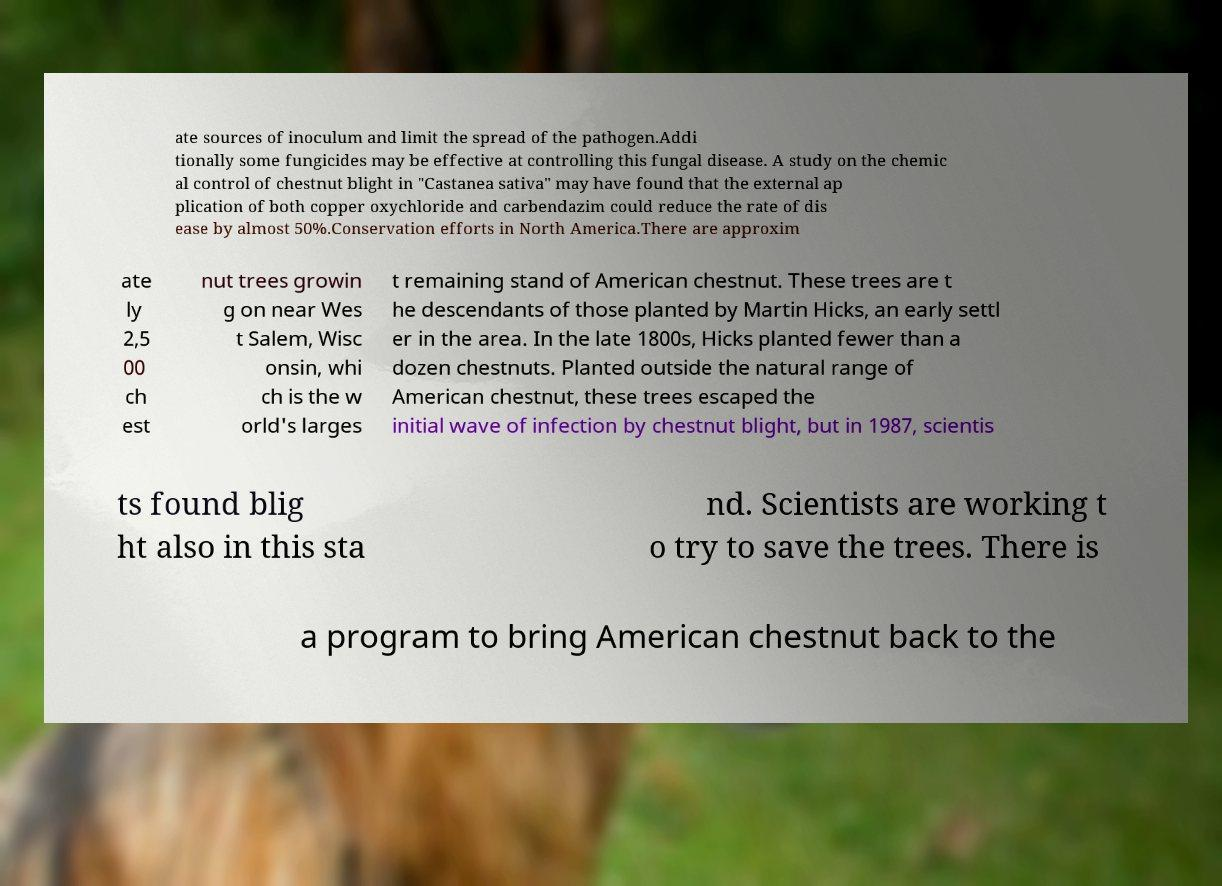There's text embedded in this image that I need extracted. Can you transcribe it verbatim? ate sources of inoculum and limit the spread of the pathogen.Addi tionally some fungicides may be effective at controlling this fungal disease. A study on the chemic al control of chestnut blight in "Castanea sativa" may have found that the external ap plication of both copper oxychloride and carbendazim could reduce the rate of dis ease by almost 50%.Conservation efforts in North America.There are approxim ate ly 2,5 00 ch est nut trees growin g on near Wes t Salem, Wisc onsin, whi ch is the w orld's larges t remaining stand of American chestnut. These trees are t he descendants of those planted by Martin Hicks, an early settl er in the area. In the late 1800s, Hicks planted fewer than a dozen chestnuts. Planted outside the natural range of American chestnut, these trees escaped the initial wave of infection by chestnut blight, but in 1987, scientis ts found blig ht also in this sta nd. Scientists are working t o try to save the trees. There is a program to bring American chestnut back to the 